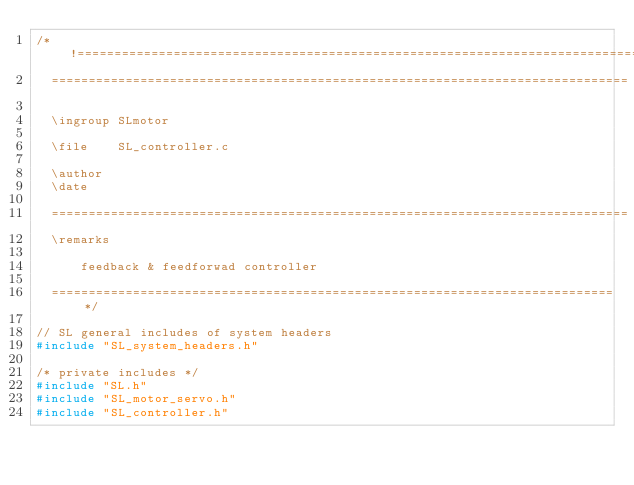Convert code to text. <code><loc_0><loc_0><loc_500><loc_500><_C_>/*!=============================================================================
  ==============================================================================

  \ingroup SLmotor

  \file    SL_controller.c

  \author 
  \date   

  ==============================================================================
  \remarks

      feedback & feedforwad controller

  ============================================================================*/

// SL general includes of system headers
#include "SL_system_headers.h"

/* private includes */
#include "SL.h"
#include "SL_motor_servo.h"
#include "SL_controller.h"</code> 